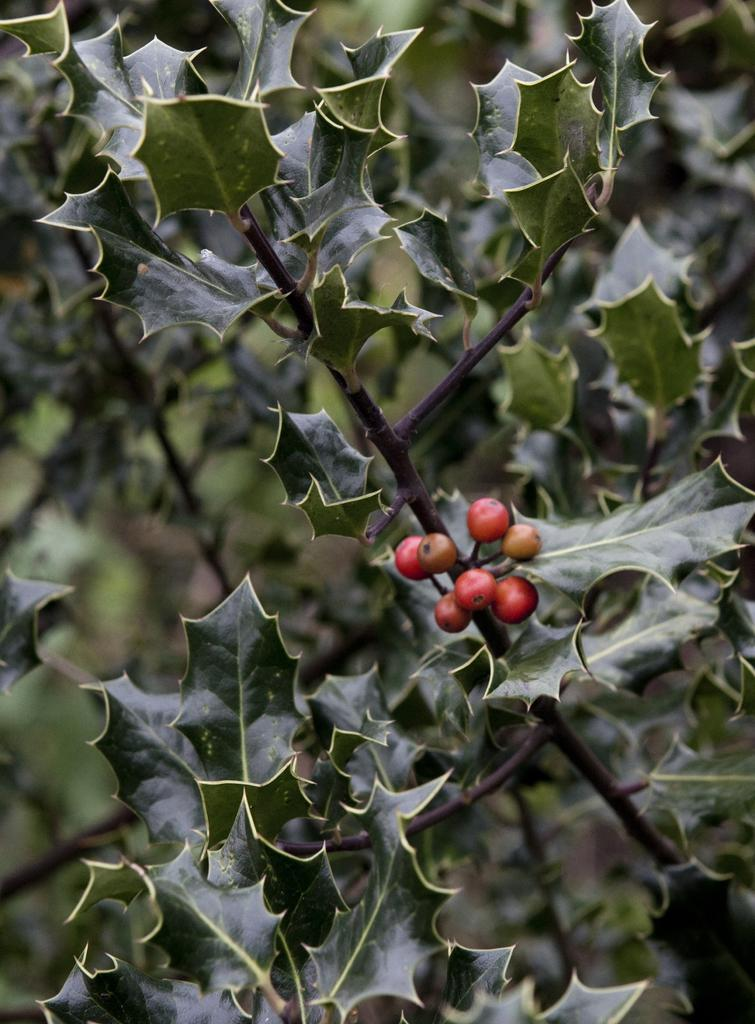What types of living organisms can be seen in the image? Plants and fruits are visible in the image. Can you describe the background of the image? The background of the image is blurred. What type of government is depicted in the image? There is no government depicted in the image; it features plants and fruits with a blurred background. How does the skate interact with the plants in the image? There is no skate present in the image; it only contains plants and fruits with a blurred background. 